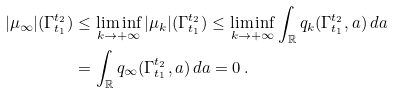<formula> <loc_0><loc_0><loc_500><loc_500>| \mu _ { \infty } | ( \Gamma _ { t _ { 1 } } ^ { t _ { 2 } } ) & \leq \liminf _ { k \rightarrow + \infty } | \mu _ { k } | ( \Gamma _ { t _ { 1 } } ^ { t _ { 2 } } ) \leq \liminf _ { k \rightarrow + \infty } \int _ { \mathbb { R } } q _ { k } ( \Gamma _ { t _ { 1 } } ^ { t _ { 2 } } , a ) \, d a \\ & = \int _ { \mathbb { R } } q _ { \infty } ( \Gamma _ { t _ { 1 } } ^ { t _ { 2 } } , a ) \, d a = 0 \, .</formula> 